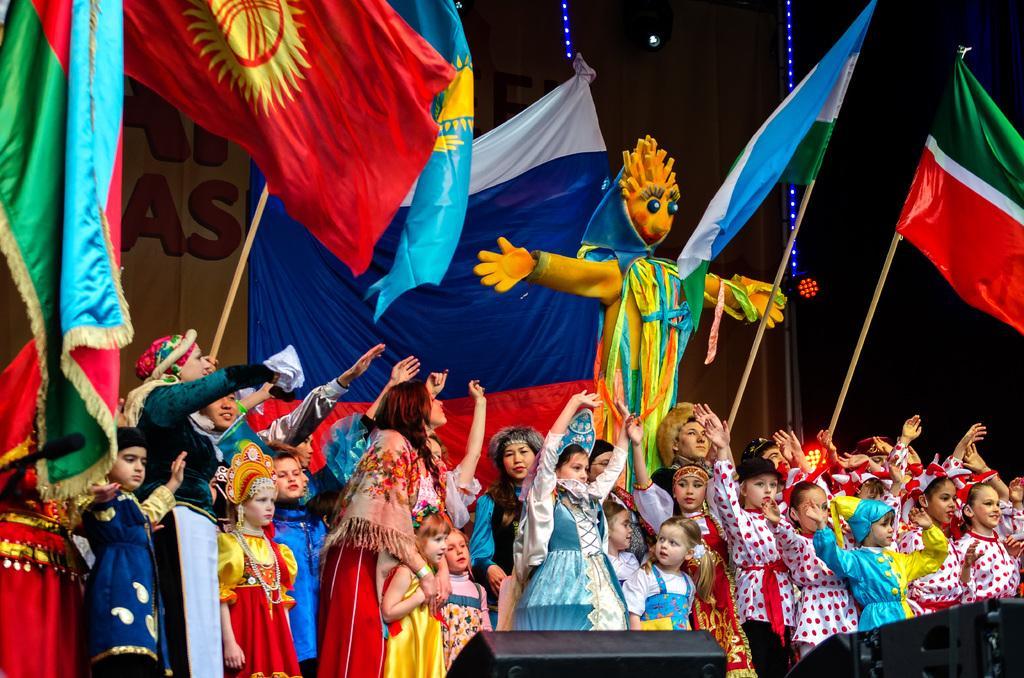Please provide a concise description of this image. In the center of the image we can see a clown. At the bottom of the image we can see the lights and a group of people are standing and wearing the costumes. In the background of the image we can see the flags, poles, banners, lights. 